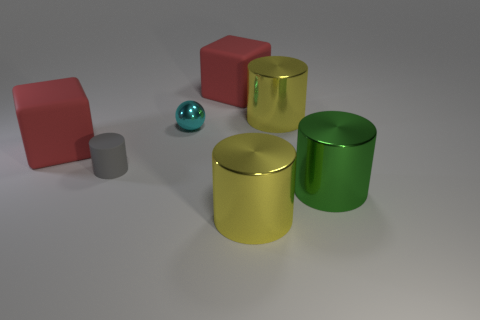Add 3 green objects. How many objects exist? 10 Subtract all balls. How many objects are left? 6 Add 5 tiny rubber cylinders. How many tiny rubber cylinders are left? 6 Add 7 big green shiny things. How many big green shiny things exist? 8 Subtract 0 yellow cubes. How many objects are left? 7 Subtract all large blue matte cylinders. Subtract all big yellow objects. How many objects are left? 5 